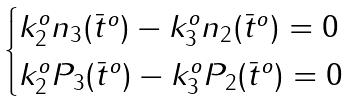Convert formula to latex. <formula><loc_0><loc_0><loc_500><loc_500>\begin{cases} k _ { 2 } ^ { o } n _ { 3 } ( \bar { t } ^ { o } ) - k _ { 3 } ^ { o } n _ { 2 } ( \bar { t } ^ { o } ) = 0 \\ k _ { 2 } ^ { o } P _ { 3 } ( \bar { t } ^ { o } ) - k _ { 3 } ^ { o } P _ { 2 } ( \bar { t } ^ { o } ) = 0 \end{cases}</formula> 